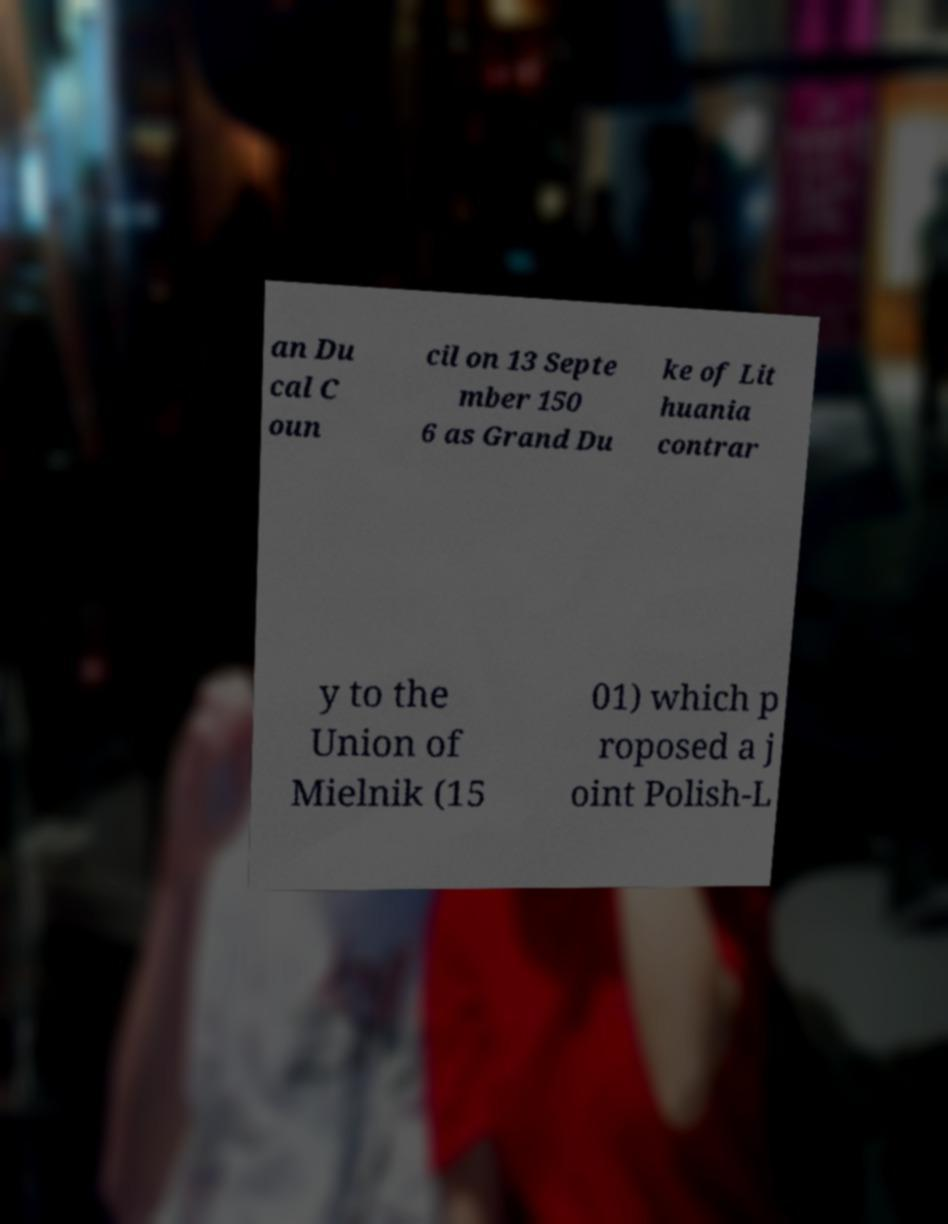Could you assist in decoding the text presented in this image and type it out clearly? an Du cal C oun cil on 13 Septe mber 150 6 as Grand Du ke of Lit huania contrar y to the Union of Mielnik (15 01) which p roposed a j oint Polish-L 